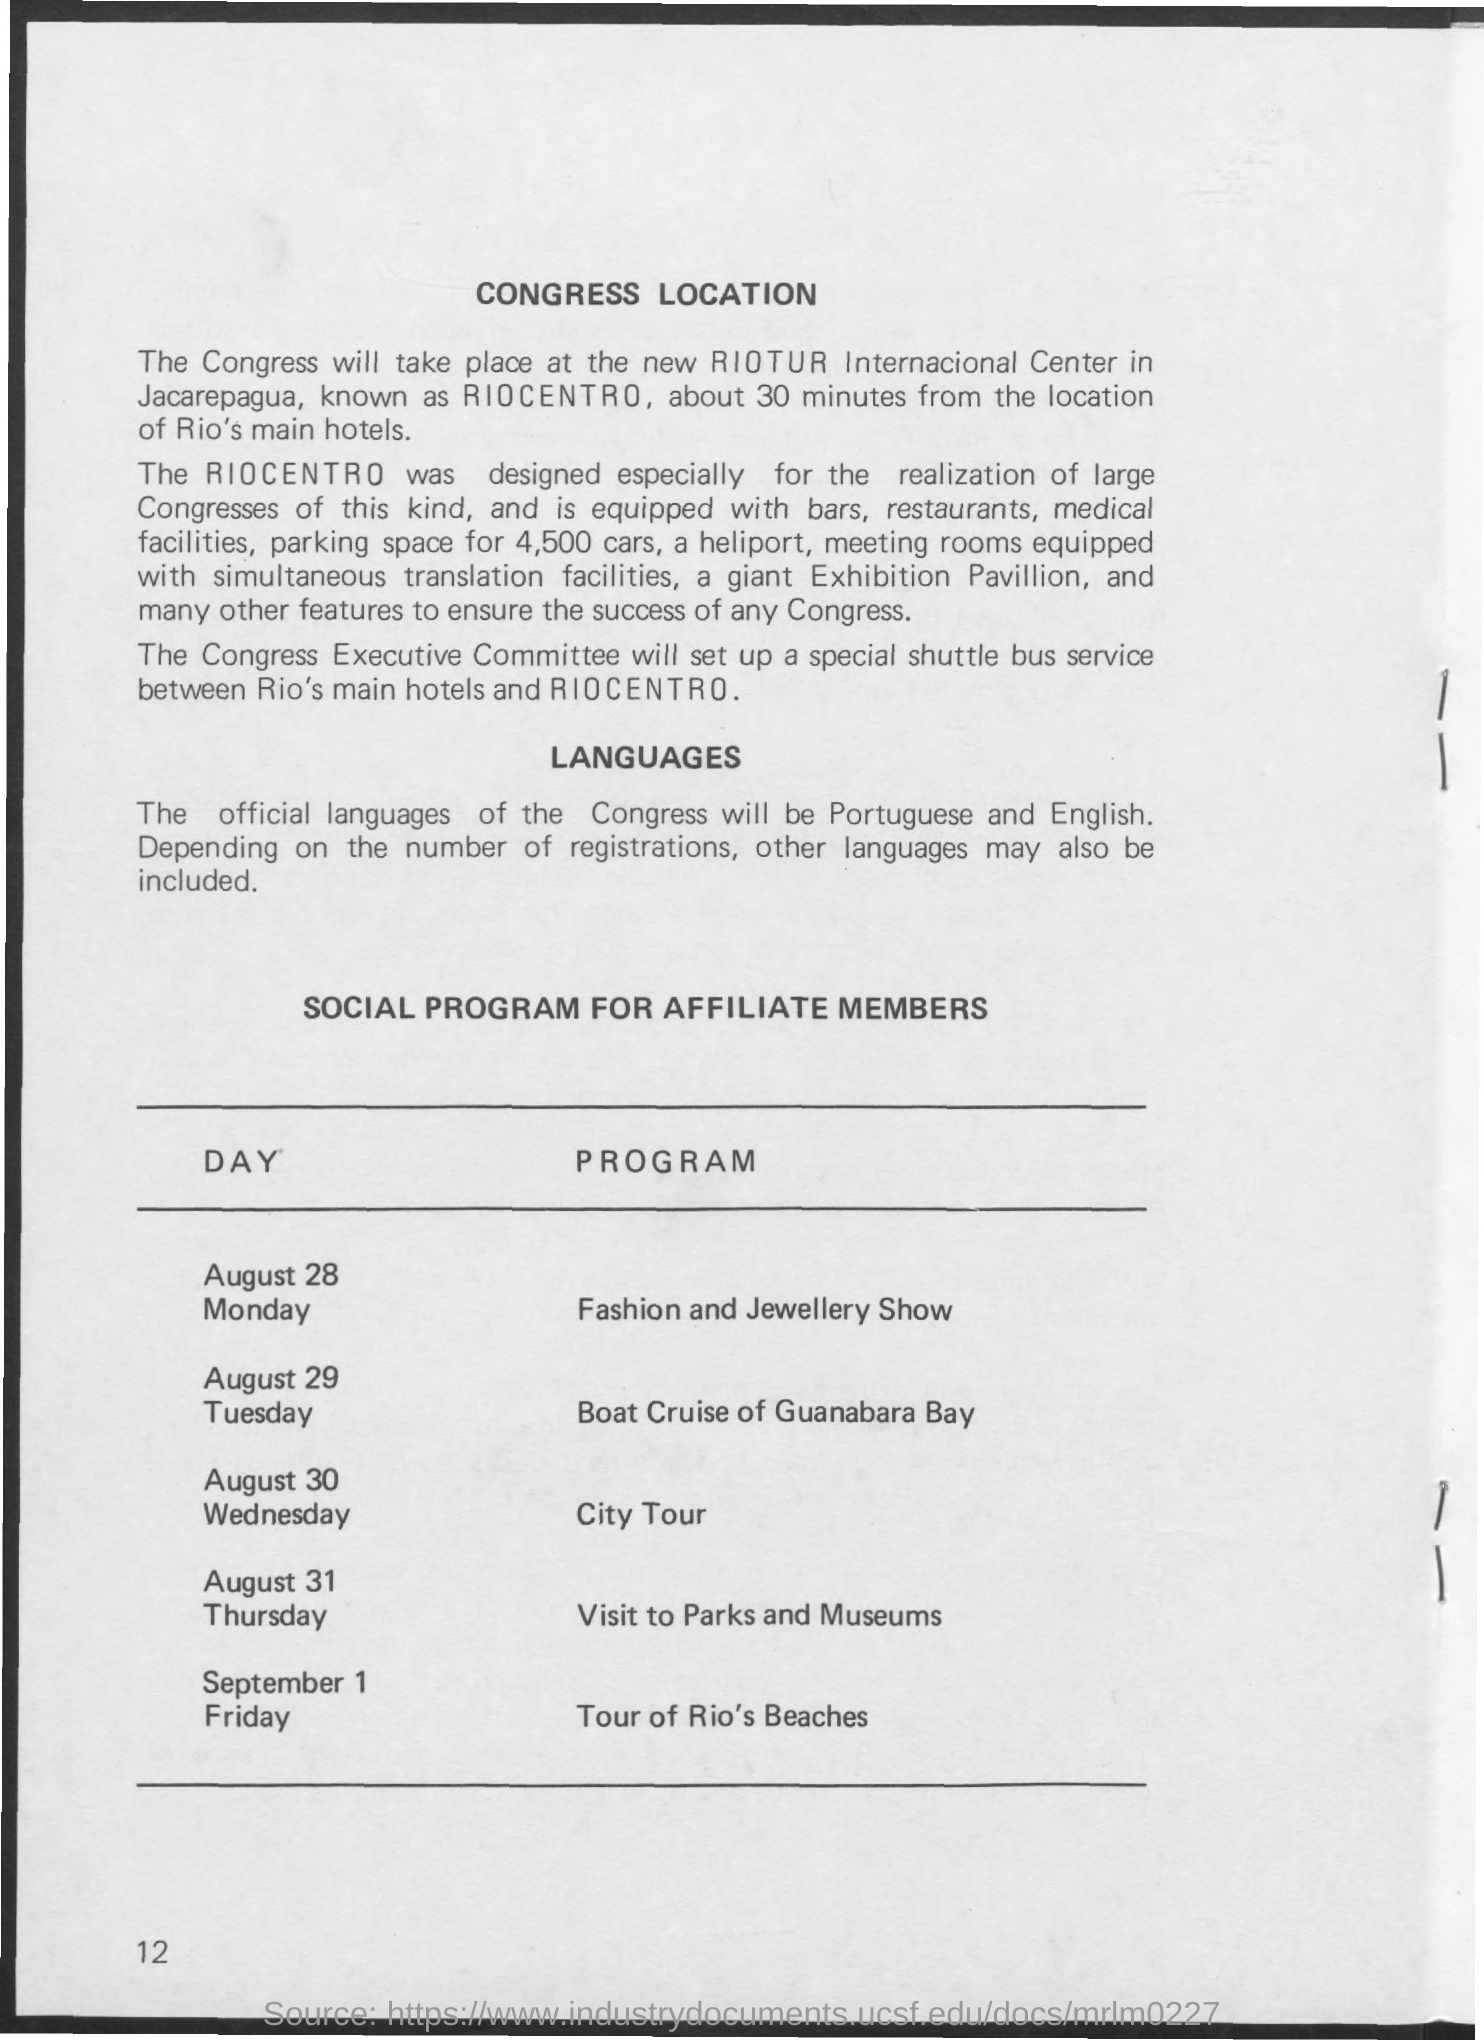Where will the Congress take place?
Provide a short and direct response. At the new riotur internacional center in jacarepagua, known as riocentro. What are the official languages of the Congress?
Your response must be concise. Portuguese and English. On which day is the Fashion and Jewellery Show?
Give a very brief answer. August 28. What is the program on August 30 Wednesday?
Your response must be concise. City Tour. For whom is the social program?
Your answer should be very brief. AFFILIATE MEMBERS. 